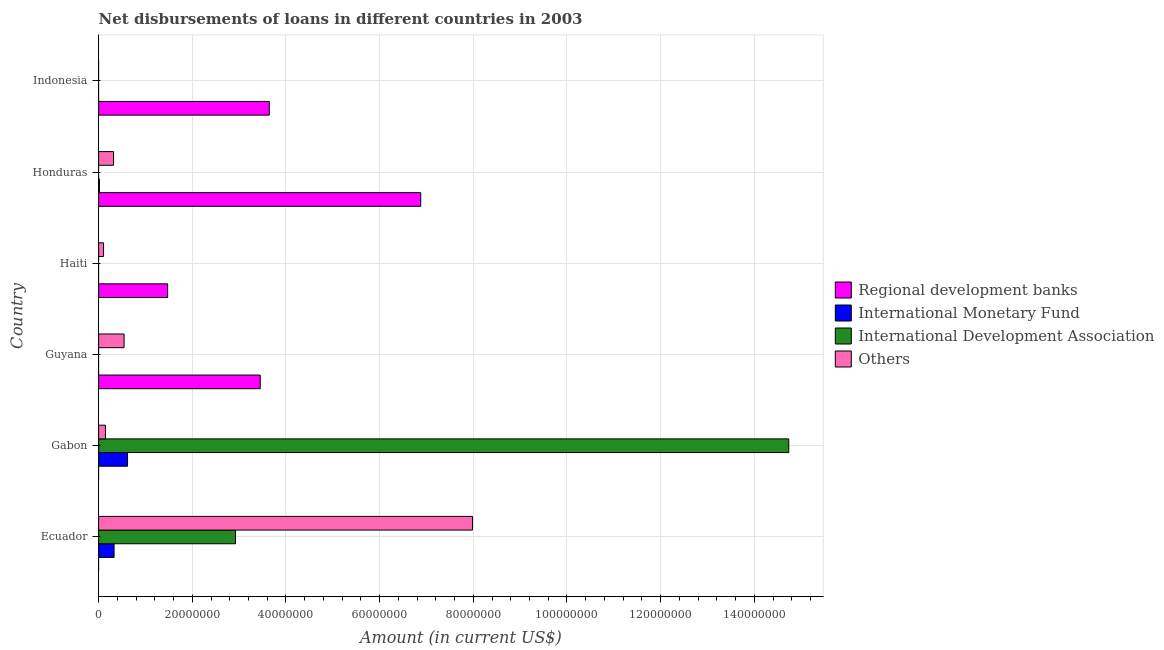Are the number of bars per tick equal to the number of legend labels?
Your response must be concise. No. Are the number of bars on each tick of the Y-axis equal?
Keep it short and to the point. No. How many bars are there on the 1st tick from the bottom?
Offer a very short reply. 3. What is the label of the 3rd group of bars from the top?
Keep it short and to the point. Haiti. What is the amount of loan disimbursed by international development association in Ecuador?
Offer a very short reply. 2.92e+07. Across all countries, what is the maximum amount of loan disimbursed by other organisations?
Your response must be concise. 7.98e+07. In which country was the amount of loan disimbursed by other organisations maximum?
Your answer should be compact. Ecuador. What is the total amount of loan disimbursed by international monetary fund in the graph?
Make the answer very short. 9.63e+06. What is the difference between the amount of loan disimbursed by other organisations in Gabon and that in Honduras?
Ensure brevity in your answer.  -1.73e+06. What is the difference between the amount of loan disimbursed by regional development banks in Guyana and the amount of loan disimbursed by other organisations in Indonesia?
Your response must be concise. 3.45e+07. What is the average amount of loan disimbursed by international monetary fund per country?
Your response must be concise. 1.61e+06. What is the difference between the amount of loan disimbursed by other organisations and amount of loan disimbursed by international monetary fund in Gabon?
Your response must be concise. -4.71e+06. In how many countries, is the amount of loan disimbursed by regional development banks greater than 80000000 US$?
Keep it short and to the point. 0. What is the ratio of the amount of loan disimbursed by other organisations in Gabon to that in Haiti?
Provide a short and direct response. 1.38. What is the difference between the highest and the second highest amount of loan disimbursed by other organisations?
Your answer should be compact. 7.44e+07. What is the difference between the highest and the lowest amount of loan disimbursed by international development association?
Give a very brief answer. 1.47e+08. Is the sum of the amount of loan disimbursed by regional development banks in Haiti and Indonesia greater than the maximum amount of loan disimbursed by international development association across all countries?
Keep it short and to the point. No. Is it the case that in every country, the sum of the amount of loan disimbursed by regional development banks and amount of loan disimbursed by international development association is greater than the sum of amount of loan disimbursed by other organisations and amount of loan disimbursed by international monetary fund?
Keep it short and to the point. Yes. How many countries are there in the graph?
Provide a short and direct response. 6. Does the graph contain any zero values?
Ensure brevity in your answer.  Yes. Where does the legend appear in the graph?
Keep it short and to the point. Center right. What is the title of the graph?
Make the answer very short. Net disbursements of loans in different countries in 2003. Does "Plant species" appear as one of the legend labels in the graph?
Provide a short and direct response. No. What is the label or title of the X-axis?
Your answer should be very brief. Amount (in current US$). What is the Amount (in current US$) of International Monetary Fund in Ecuador?
Provide a succinct answer. 3.30e+06. What is the Amount (in current US$) of International Development Association in Ecuador?
Your answer should be compact. 2.92e+07. What is the Amount (in current US$) of Others in Ecuador?
Your answer should be very brief. 7.98e+07. What is the Amount (in current US$) of International Monetary Fund in Gabon?
Provide a succinct answer. 6.17e+06. What is the Amount (in current US$) in International Development Association in Gabon?
Give a very brief answer. 1.47e+08. What is the Amount (in current US$) in Others in Gabon?
Give a very brief answer. 1.46e+06. What is the Amount (in current US$) of Regional development banks in Guyana?
Offer a terse response. 3.45e+07. What is the Amount (in current US$) of International Monetary Fund in Guyana?
Your answer should be compact. 0. What is the Amount (in current US$) of International Development Association in Guyana?
Offer a terse response. 0. What is the Amount (in current US$) of Others in Guyana?
Your response must be concise. 5.43e+06. What is the Amount (in current US$) in Regional development banks in Haiti?
Offer a terse response. 1.47e+07. What is the Amount (in current US$) of International Development Association in Haiti?
Make the answer very short. 0. What is the Amount (in current US$) of Others in Haiti?
Your response must be concise. 1.05e+06. What is the Amount (in current US$) of Regional development banks in Honduras?
Your answer should be compact. 6.88e+07. What is the Amount (in current US$) in International Monetary Fund in Honduras?
Your answer should be very brief. 1.64e+05. What is the Amount (in current US$) in Others in Honduras?
Your answer should be compact. 3.18e+06. What is the Amount (in current US$) of Regional development banks in Indonesia?
Provide a short and direct response. 3.64e+07. What is the Amount (in current US$) of International Development Association in Indonesia?
Your answer should be very brief. 0. Across all countries, what is the maximum Amount (in current US$) in Regional development banks?
Offer a terse response. 6.88e+07. Across all countries, what is the maximum Amount (in current US$) of International Monetary Fund?
Give a very brief answer. 6.17e+06. Across all countries, what is the maximum Amount (in current US$) in International Development Association?
Offer a very short reply. 1.47e+08. Across all countries, what is the maximum Amount (in current US$) of Others?
Offer a very short reply. 7.98e+07. Across all countries, what is the minimum Amount (in current US$) in Others?
Ensure brevity in your answer.  0. What is the total Amount (in current US$) in Regional development banks in the graph?
Your response must be concise. 1.54e+08. What is the total Amount (in current US$) in International Monetary Fund in the graph?
Ensure brevity in your answer.  9.63e+06. What is the total Amount (in current US$) in International Development Association in the graph?
Offer a very short reply. 1.77e+08. What is the total Amount (in current US$) of Others in the graph?
Make the answer very short. 9.10e+07. What is the difference between the Amount (in current US$) in International Monetary Fund in Ecuador and that in Gabon?
Keep it short and to the point. -2.87e+06. What is the difference between the Amount (in current US$) in International Development Association in Ecuador and that in Gabon?
Make the answer very short. -1.18e+08. What is the difference between the Amount (in current US$) in Others in Ecuador and that in Gabon?
Your response must be concise. 7.84e+07. What is the difference between the Amount (in current US$) in Others in Ecuador and that in Guyana?
Your response must be concise. 7.44e+07. What is the difference between the Amount (in current US$) in Others in Ecuador and that in Haiti?
Make the answer very short. 7.88e+07. What is the difference between the Amount (in current US$) of International Monetary Fund in Ecuador and that in Honduras?
Make the answer very short. 3.13e+06. What is the difference between the Amount (in current US$) in Others in Ecuador and that in Honduras?
Make the answer very short. 7.66e+07. What is the difference between the Amount (in current US$) of Others in Gabon and that in Guyana?
Keep it short and to the point. -3.98e+06. What is the difference between the Amount (in current US$) in Others in Gabon and that in Haiti?
Your answer should be compact. 4.04e+05. What is the difference between the Amount (in current US$) in International Monetary Fund in Gabon and that in Honduras?
Your answer should be very brief. 6.00e+06. What is the difference between the Amount (in current US$) of Others in Gabon and that in Honduras?
Your answer should be compact. -1.73e+06. What is the difference between the Amount (in current US$) of Regional development banks in Guyana and that in Haiti?
Keep it short and to the point. 1.98e+07. What is the difference between the Amount (in current US$) of Others in Guyana and that in Haiti?
Your answer should be very brief. 4.38e+06. What is the difference between the Amount (in current US$) of Regional development banks in Guyana and that in Honduras?
Offer a very short reply. -3.43e+07. What is the difference between the Amount (in current US$) of Others in Guyana and that in Honduras?
Provide a short and direct response. 2.25e+06. What is the difference between the Amount (in current US$) of Regional development banks in Guyana and that in Indonesia?
Provide a short and direct response. -1.93e+06. What is the difference between the Amount (in current US$) of Regional development banks in Haiti and that in Honduras?
Make the answer very short. -5.40e+07. What is the difference between the Amount (in current US$) of Others in Haiti and that in Honduras?
Your response must be concise. -2.13e+06. What is the difference between the Amount (in current US$) of Regional development banks in Haiti and that in Indonesia?
Ensure brevity in your answer.  -2.17e+07. What is the difference between the Amount (in current US$) of Regional development banks in Honduras and that in Indonesia?
Your answer should be very brief. 3.23e+07. What is the difference between the Amount (in current US$) in International Monetary Fund in Ecuador and the Amount (in current US$) in International Development Association in Gabon?
Your answer should be very brief. -1.44e+08. What is the difference between the Amount (in current US$) of International Monetary Fund in Ecuador and the Amount (in current US$) of Others in Gabon?
Keep it short and to the point. 1.84e+06. What is the difference between the Amount (in current US$) in International Development Association in Ecuador and the Amount (in current US$) in Others in Gabon?
Make the answer very short. 2.78e+07. What is the difference between the Amount (in current US$) in International Monetary Fund in Ecuador and the Amount (in current US$) in Others in Guyana?
Your answer should be very brief. -2.14e+06. What is the difference between the Amount (in current US$) in International Development Association in Ecuador and the Amount (in current US$) in Others in Guyana?
Provide a short and direct response. 2.38e+07. What is the difference between the Amount (in current US$) in International Monetary Fund in Ecuador and the Amount (in current US$) in Others in Haiti?
Keep it short and to the point. 2.24e+06. What is the difference between the Amount (in current US$) in International Development Association in Ecuador and the Amount (in current US$) in Others in Haiti?
Provide a short and direct response. 2.82e+07. What is the difference between the Amount (in current US$) of International Monetary Fund in Ecuador and the Amount (in current US$) of Others in Honduras?
Keep it short and to the point. 1.13e+05. What is the difference between the Amount (in current US$) of International Development Association in Ecuador and the Amount (in current US$) of Others in Honduras?
Give a very brief answer. 2.60e+07. What is the difference between the Amount (in current US$) of International Monetary Fund in Gabon and the Amount (in current US$) of Others in Guyana?
Ensure brevity in your answer.  7.35e+05. What is the difference between the Amount (in current US$) in International Development Association in Gabon and the Amount (in current US$) in Others in Guyana?
Provide a succinct answer. 1.42e+08. What is the difference between the Amount (in current US$) in International Monetary Fund in Gabon and the Amount (in current US$) in Others in Haiti?
Make the answer very short. 5.12e+06. What is the difference between the Amount (in current US$) of International Development Association in Gabon and the Amount (in current US$) of Others in Haiti?
Your answer should be very brief. 1.46e+08. What is the difference between the Amount (in current US$) of International Monetary Fund in Gabon and the Amount (in current US$) of Others in Honduras?
Keep it short and to the point. 2.98e+06. What is the difference between the Amount (in current US$) of International Development Association in Gabon and the Amount (in current US$) of Others in Honduras?
Give a very brief answer. 1.44e+08. What is the difference between the Amount (in current US$) in Regional development banks in Guyana and the Amount (in current US$) in Others in Haiti?
Offer a terse response. 3.35e+07. What is the difference between the Amount (in current US$) of Regional development banks in Guyana and the Amount (in current US$) of International Monetary Fund in Honduras?
Offer a terse response. 3.43e+07. What is the difference between the Amount (in current US$) in Regional development banks in Guyana and the Amount (in current US$) in Others in Honduras?
Give a very brief answer. 3.13e+07. What is the difference between the Amount (in current US$) of Regional development banks in Haiti and the Amount (in current US$) of International Monetary Fund in Honduras?
Offer a terse response. 1.46e+07. What is the difference between the Amount (in current US$) of Regional development banks in Haiti and the Amount (in current US$) of Others in Honduras?
Offer a very short reply. 1.16e+07. What is the average Amount (in current US$) in Regional development banks per country?
Ensure brevity in your answer.  2.57e+07. What is the average Amount (in current US$) of International Monetary Fund per country?
Your response must be concise. 1.61e+06. What is the average Amount (in current US$) in International Development Association per country?
Offer a terse response. 2.94e+07. What is the average Amount (in current US$) in Others per country?
Your response must be concise. 1.52e+07. What is the difference between the Amount (in current US$) in International Monetary Fund and Amount (in current US$) in International Development Association in Ecuador?
Your response must be concise. -2.59e+07. What is the difference between the Amount (in current US$) of International Monetary Fund and Amount (in current US$) of Others in Ecuador?
Your answer should be very brief. -7.65e+07. What is the difference between the Amount (in current US$) of International Development Association and Amount (in current US$) of Others in Ecuador?
Your answer should be compact. -5.06e+07. What is the difference between the Amount (in current US$) in International Monetary Fund and Amount (in current US$) in International Development Association in Gabon?
Your answer should be very brief. -1.41e+08. What is the difference between the Amount (in current US$) of International Monetary Fund and Amount (in current US$) of Others in Gabon?
Give a very brief answer. 4.71e+06. What is the difference between the Amount (in current US$) of International Development Association and Amount (in current US$) of Others in Gabon?
Keep it short and to the point. 1.46e+08. What is the difference between the Amount (in current US$) of Regional development banks and Amount (in current US$) of Others in Guyana?
Offer a terse response. 2.91e+07. What is the difference between the Amount (in current US$) of Regional development banks and Amount (in current US$) of Others in Haiti?
Provide a succinct answer. 1.37e+07. What is the difference between the Amount (in current US$) in Regional development banks and Amount (in current US$) in International Monetary Fund in Honduras?
Your answer should be compact. 6.86e+07. What is the difference between the Amount (in current US$) in Regional development banks and Amount (in current US$) in Others in Honduras?
Offer a very short reply. 6.56e+07. What is the difference between the Amount (in current US$) in International Monetary Fund and Amount (in current US$) in Others in Honduras?
Offer a very short reply. -3.02e+06. What is the ratio of the Amount (in current US$) of International Monetary Fund in Ecuador to that in Gabon?
Keep it short and to the point. 0.53. What is the ratio of the Amount (in current US$) of International Development Association in Ecuador to that in Gabon?
Provide a succinct answer. 0.2. What is the ratio of the Amount (in current US$) of Others in Ecuador to that in Gabon?
Your answer should be compact. 54.79. What is the ratio of the Amount (in current US$) in Others in Ecuador to that in Guyana?
Keep it short and to the point. 14.69. What is the ratio of the Amount (in current US$) of Others in Ecuador to that in Haiti?
Offer a terse response. 75.81. What is the ratio of the Amount (in current US$) in International Monetary Fund in Ecuador to that in Honduras?
Give a very brief answer. 20.11. What is the ratio of the Amount (in current US$) in Others in Ecuador to that in Honduras?
Offer a terse response. 25.06. What is the ratio of the Amount (in current US$) of Others in Gabon to that in Guyana?
Your answer should be very brief. 0.27. What is the ratio of the Amount (in current US$) in Others in Gabon to that in Haiti?
Your response must be concise. 1.38. What is the ratio of the Amount (in current US$) of International Monetary Fund in Gabon to that in Honduras?
Your answer should be compact. 37.62. What is the ratio of the Amount (in current US$) in Others in Gabon to that in Honduras?
Make the answer very short. 0.46. What is the ratio of the Amount (in current US$) in Regional development banks in Guyana to that in Haiti?
Offer a very short reply. 2.34. What is the ratio of the Amount (in current US$) of Others in Guyana to that in Haiti?
Offer a terse response. 5.16. What is the ratio of the Amount (in current US$) in Regional development banks in Guyana to that in Honduras?
Ensure brevity in your answer.  0.5. What is the ratio of the Amount (in current US$) of Others in Guyana to that in Honduras?
Offer a terse response. 1.71. What is the ratio of the Amount (in current US$) in Regional development banks in Guyana to that in Indonesia?
Keep it short and to the point. 0.95. What is the ratio of the Amount (in current US$) in Regional development banks in Haiti to that in Honduras?
Provide a short and direct response. 0.21. What is the ratio of the Amount (in current US$) in Others in Haiti to that in Honduras?
Keep it short and to the point. 0.33. What is the ratio of the Amount (in current US$) of Regional development banks in Haiti to that in Indonesia?
Your answer should be compact. 0.4. What is the ratio of the Amount (in current US$) in Regional development banks in Honduras to that in Indonesia?
Keep it short and to the point. 1.89. What is the difference between the highest and the second highest Amount (in current US$) of Regional development banks?
Offer a very short reply. 3.23e+07. What is the difference between the highest and the second highest Amount (in current US$) in International Monetary Fund?
Provide a succinct answer. 2.87e+06. What is the difference between the highest and the second highest Amount (in current US$) of Others?
Your response must be concise. 7.44e+07. What is the difference between the highest and the lowest Amount (in current US$) in Regional development banks?
Provide a succinct answer. 6.88e+07. What is the difference between the highest and the lowest Amount (in current US$) of International Monetary Fund?
Give a very brief answer. 6.17e+06. What is the difference between the highest and the lowest Amount (in current US$) in International Development Association?
Keep it short and to the point. 1.47e+08. What is the difference between the highest and the lowest Amount (in current US$) in Others?
Give a very brief answer. 7.98e+07. 